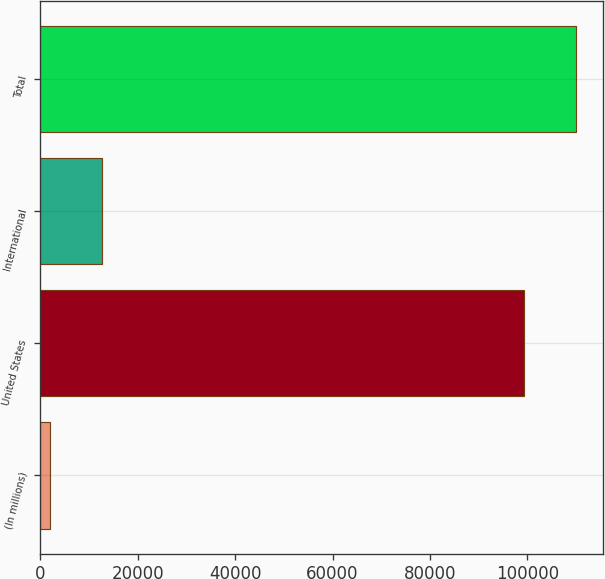<chart> <loc_0><loc_0><loc_500><loc_500><bar_chart><fcel>(In millions)<fcel>United States<fcel>International<fcel>Total<nl><fcel>2010<fcel>99387<fcel>12679.2<fcel>110056<nl></chart> 